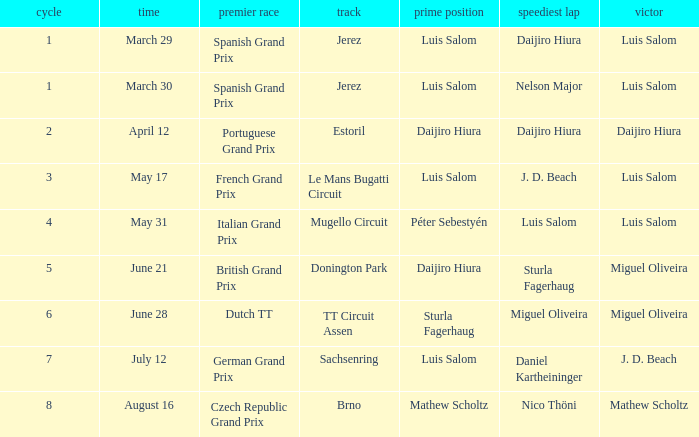Luis Salom had the fastest lap on which circuits?  Mugello Circuit. 